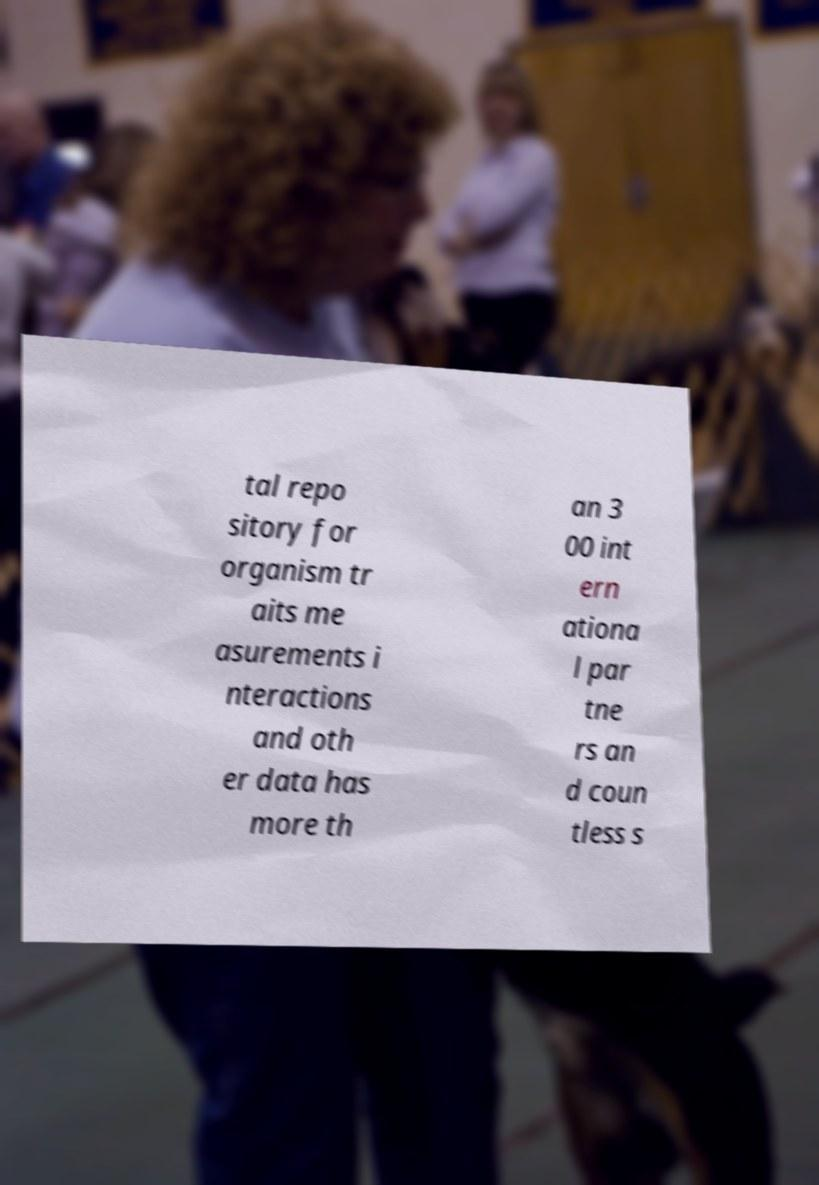Could you assist in decoding the text presented in this image and type it out clearly? tal repo sitory for organism tr aits me asurements i nteractions and oth er data has more th an 3 00 int ern ationa l par tne rs an d coun tless s 